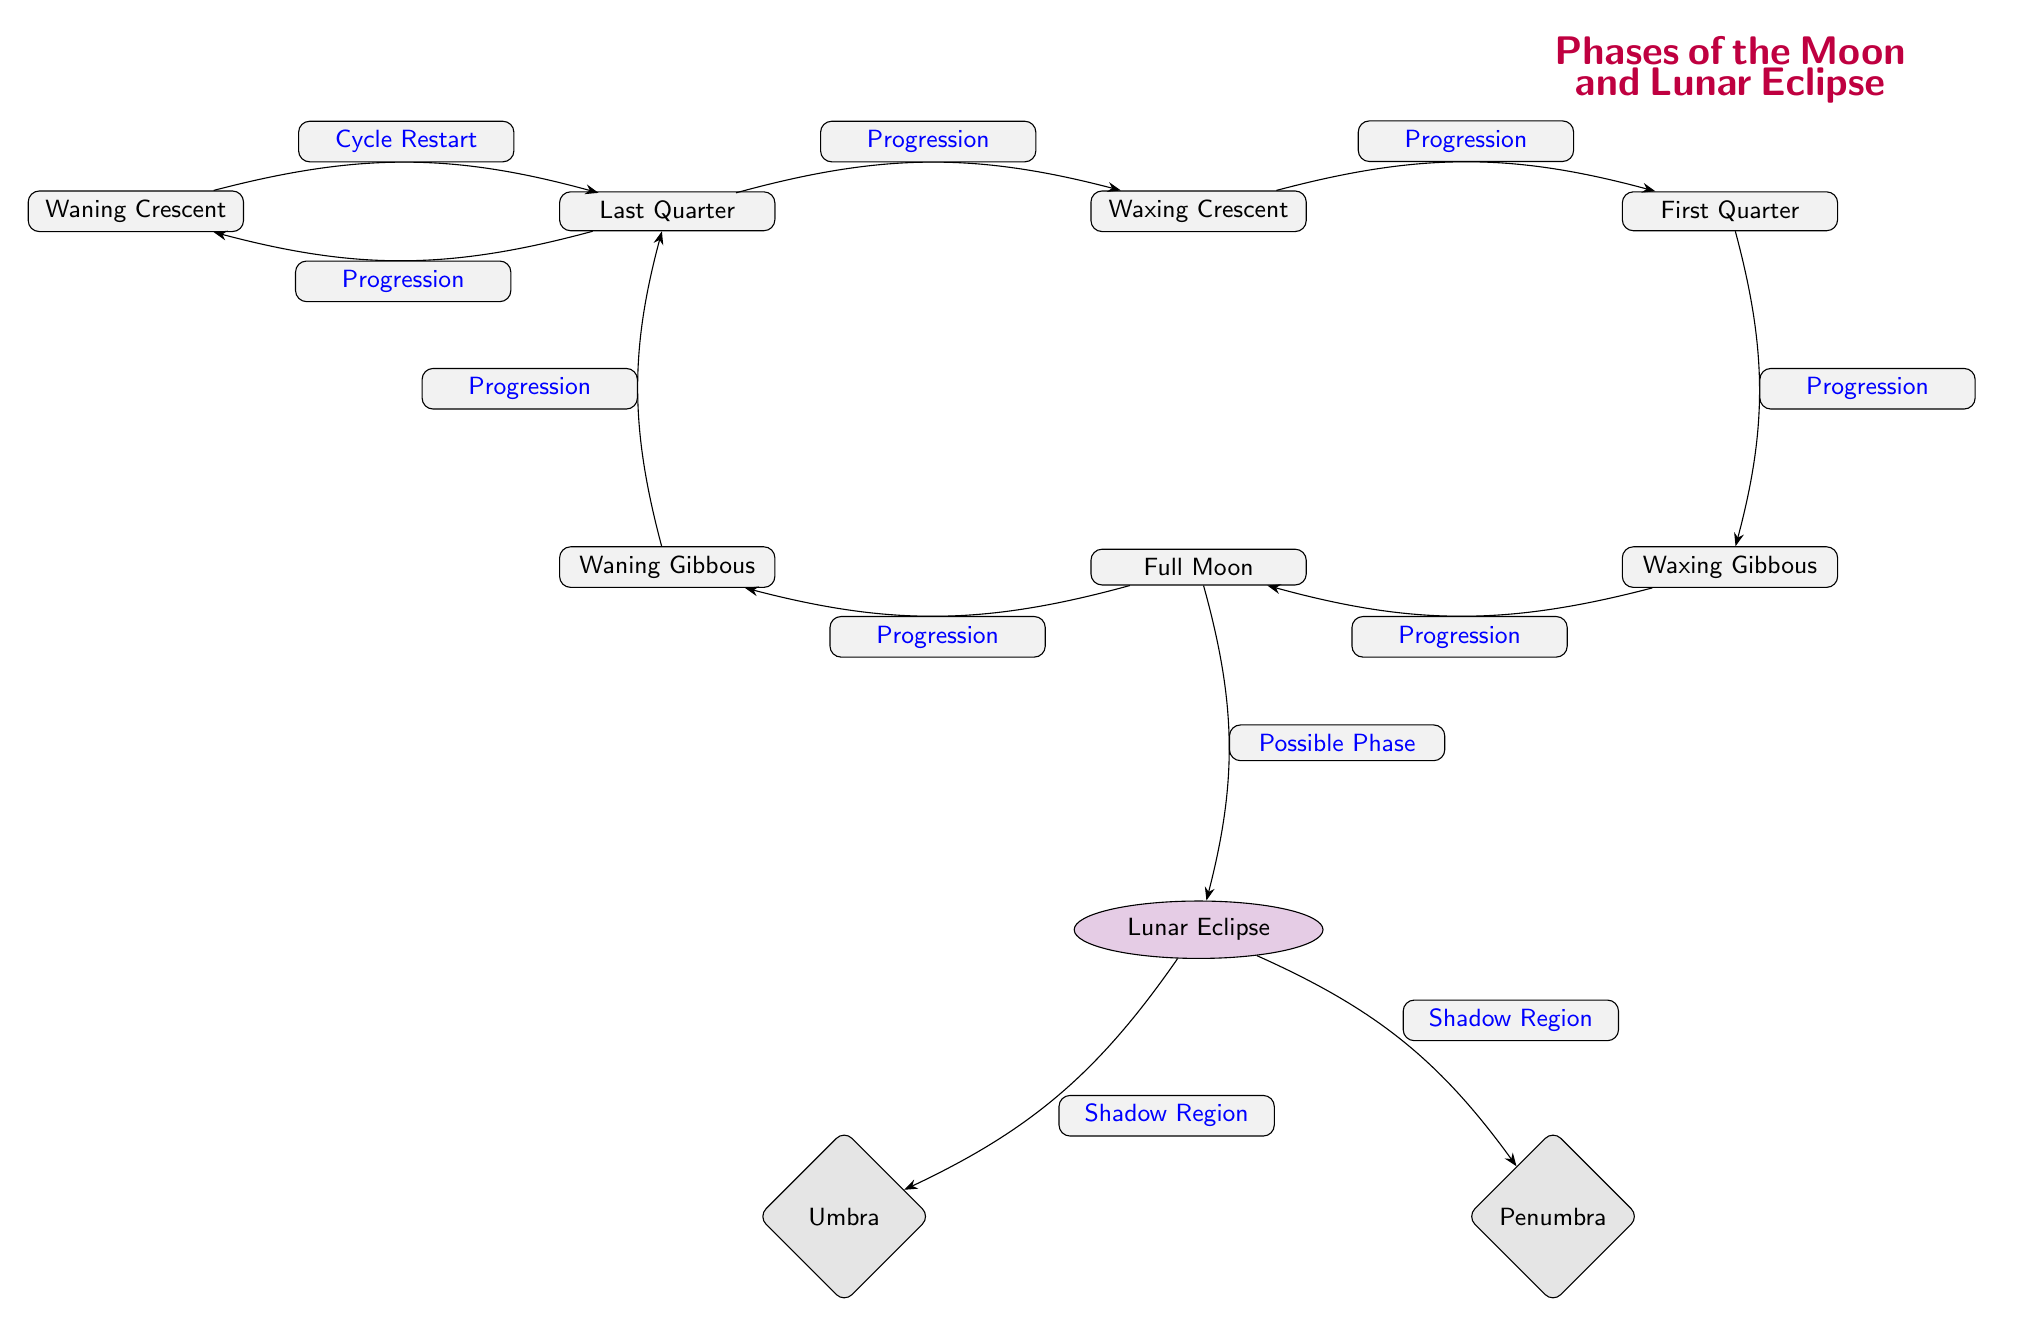What is the last phase before the New Moon? The last phase before the New Moon is the Waning Crescent, as it cycles before returning to the new phase.
Answer: Waning Crescent How many total phases of the Moon are shown in the diagram? The diagram displays eight different phases of the Moon, each represented as a node.
Answer: 8 What phase can occur during a Lunar Eclipse? The phase that can occur during a Lunar Eclipse is the Full Moon, as the alignment required happens only during this phase.
Answer: Full Moon Which two shadows are associated with a Lunar Eclipse? The shadows associated with a Lunar Eclipse are the Umbra and Penumbra, which are indicated as regions near the Lunar Eclipse node.
Answer: Umbra and Penumbra What is the relationship between the Full Moon and the Lunar Eclipse in the diagram? The Full Moon has a possible phase relationship with the Lunar Eclipse, indicating that during this phase, a Lunar Eclipse can occur.
Answer: Possible Phase What phase comes after the First Quarter? The phase that comes after the First Quarter is the Waxing Gibbous, according to the progression flow depicted in the diagram.
Answer: Waxing Gibbous What is the direction of the progression from Waning Gibbous? The direction of the progression from Waning Gibbous moves towards the Last Quarter in the diagram, indicating the sequence of phases.
Answer: Last Quarter How many edges are there in total connecting the Moon phases? There are seven edges connecting the Moon phases in a sequential progression, showing the transition from one phase to another.
Answer: 7 What is the starting point of the lunar cycle in this diagram? The starting point of the lunar cycle is the New Moon, which is the first node in the sequence of phases.
Answer: New Moon 